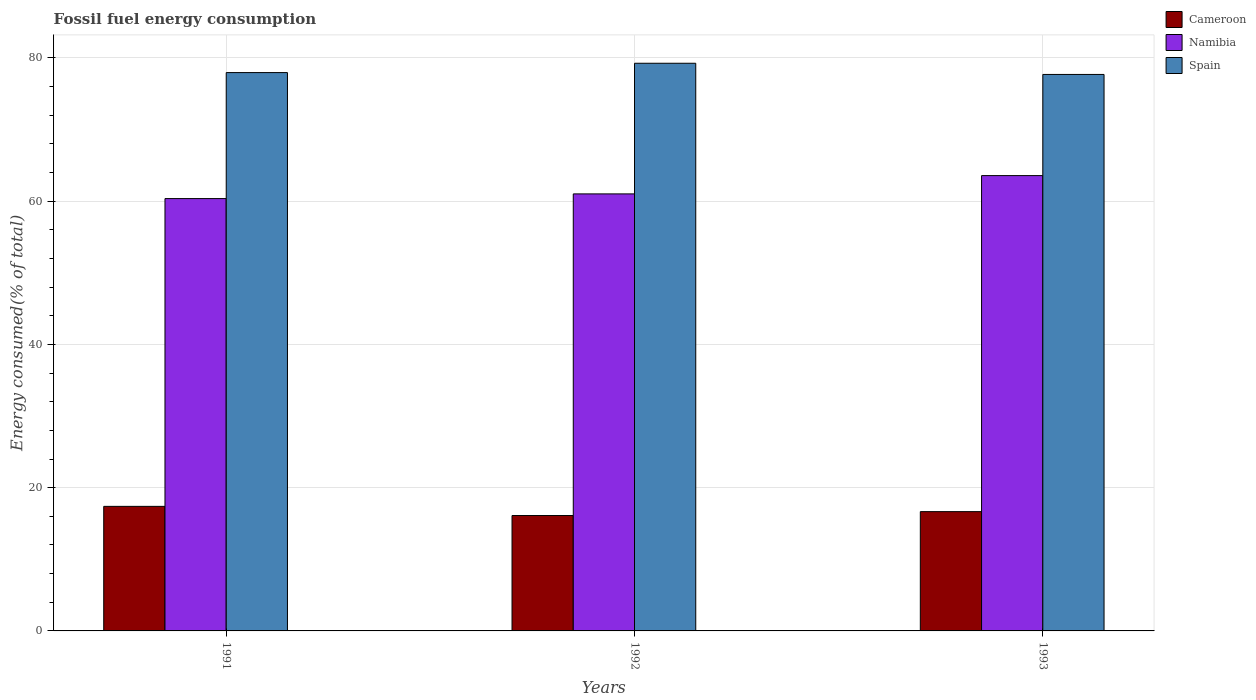How many different coloured bars are there?
Your answer should be very brief. 3. Are the number of bars per tick equal to the number of legend labels?
Offer a very short reply. Yes. Are the number of bars on each tick of the X-axis equal?
Give a very brief answer. Yes. How many bars are there on the 3rd tick from the right?
Keep it short and to the point. 3. In how many cases, is the number of bars for a given year not equal to the number of legend labels?
Your answer should be very brief. 0. What is the percentage of energy consumed in Cameroon in 1991?
Your answer should be very brief. 17.39. Across all years, what is the maximum percentage of energy consumed in Cameroon?
Your response must be concise. 17.39. Across all years, what is the minimum percentage of energy consumed in Cameroon?
Your answer should be very brief. 16.11. In which year was the percentage of energy consumed in Namibia minimum?
Keep it short and to the point. 1991. What is the total percentage of energy consumed in Spain in the graph?
Your answer should be compact. 234.9. What is the difference between the percentage of energy consumed in Namibia in 1991 and that in 1993?
Give a very brief answer. -3.21. What is the difference between the percentage of energy consumed in Cameroon in 1993 and the percentage of energy consumed in Spain in 1991?
Your answer should be very brief. -61.3. What is the average percentage of energy consumed in Spain per year?
Your answer should be very brief. 78.3. In the year 1992, what is the difference between the percentage of energy consumed in Namibia and percentage of energy consumed in Spain?
Your answer should be compact. -18.24. What is the ratio of the percentage of energy consumed in Cameroon in 1991 to that in 1992?
Make the answer very short. 1.08. Is the percentage of energy consumed in Namibia in 1991 less than that in 1993?
Your answer should be compact. Yes. What is the difference between the highest and the second highest percentage of energy consumed in Cameroon?
Your answer should be compact. 0.73. What is the difference between the highest and the lowest percentage of energy consumed in Spain?
Give a very brief answer. 1.56. Is the sum of the percentage of energy consumed in Cameroon in 1991 and 1992 greater than the maximum percentage of energy consumed in Namibia across all years?
Provide a short and direct response. No. What does the 3rd bar from the right in 1992 represents?
Provide a succinct answer. Cameroon. How many years are there in the graph?
Make the answer very short. 3. Are the values on the major ticks of Y-axis written in scientific E-notation?
Your answer should be very brief. No. How many legend labels are there?
Give a very brief answer. 3. What is the title of the graph?
Ensure brevity in your answer.  Fossil fuel energy consumption. Does "United States" appear as one of the legend labels in the graph?
Your answer should be compact. No. What is the label or title of the X-axis?
Give a very brief answer. Years. What is the label or title of the Y-axis?
Keep it short and to the point. Energy consumed(% of total). What is the Energy consumed(% of total) of Cameroon in 1991?
Your answer should be very brief. 17.39. What is the Energy consumed(% of total) in Namibia in 1991?
Give a very brief answer. 60.36. What is the Energy consumed(% of total) of Spain in 1991?
Ensure brevity in your answer.  77.95. What is the Energy consumed(% of total) in Cameroon in 1992?
Make the answer very short. 16.11. What is the Energy consumed(% of total) in Namibia in 1992?
Keep it short and to the point. 61.02. What is the Energy consumed(% of total) in Spain in 1992?
Keep it short and to the point. 79.25. What is the Energy consumed(% of total) in Cameroon in 1993?
Provide a short and direct response. 16.65. What is the Energy consumed(% of total) in Namibia in 1993?
Provide a succinct answer. 63.57. What is the Energy consumed(% of total) in Spain in 1993?
Your response must be concise. 77.69. Across all years, what is the maximum Energy consumed(% of total) in Cameroon?
Your response must be concise. 17.39. Across all years, what is the maximum Energy consumed(% of total) in Namibia?
Make the answer very short. 63.57. Across all years, what is the maximum Energy consumed(% of total) of Spain?
Your response must be concise. 79.25. Across all years, what is the minimum Energy consumed(% of total) of Cameroon?
Give a very brief answer. 16.11. Across all years, what is the minimum Energy consumed(% of total) in Namibia?
Provide a succinct answer. 60.36. Across all years, what is the minimum Energy consumed(% of total) of Spain?
Provide a short and direct response. 77.69. What is the total Energy consumed(% of total) in Cameroon in the graph?
Offer a terse response. 50.15. What is the total Energy consumed(% of total) of Namibia in the graph?
Your answer should be compact. 184.94. What is the total Energy consumed(% of total) in Spain in the graph?
Your answer should be compact. 234.9. What is the difference between the Energy consumed(% of total) in Cameroon in 1991 and that in 1992?
Ensure brevity in your answer.  1.28. What is the difference between the Energy consumed(% of total) of Namibia in 1991 and that in 1992?
Ensure brevity in your answer.  -0.66. What is the difference between the Energy consumed(% of total) of Spain in 1991 and that in 1992?
Keep it short and to the point. -1.3. What is the difference between the Energy consumed(% of total) in Cameroon in 1991 and that in 1993?
Provide a short and direct response. 0.73. What is the difference between the Energy consumed(% of total) in Namibia in 1991 and that in 1993?
Make the answer very short. -3.21. What is the difference between the Energy consumed(% of total) in Spain in 1991 and that in 1993?
Give a very brief answer. 0.26. What is the difference between the Energy consumed(% of total) in Cameroon in 1992 and that in 1993?
Your answer should be compact. -0.54. What is the difference between the Energy consumed(% of total) of Namibia in 1992 and that in 1993?
Keep it short and to the point. -2.55. What is the difference between the Energy consumed(% of total) of Spain in 1992 and that in 1993?
Offer a very short reply. 1.56. What is the difference between the Energy consumed(% of total) in Cameroon in 1991 and the Energy consumed(% of total) in Namibia in 1992?
Your response must be concise. -43.63. What is the difference between the Energy consumed(% of total) of Cameroon in 1991 and the Energy consumed(% of total) of Spain in 1992?
Your answer should be compact. -61.87. What is the difference between the Energy consumed(% of total) of Namibia in 1991 and the Energy consumed(% of total) of Spain in 1992?
Give a very brief answer. -18.89. What is the difference between the Energy consumed(% of total) of Cameroon in 1991 and the Energy consumed(% of total) of Namibia in 1993?
Give a very brief answer. -46.18. What is the difference between the Energy consumed(% of total) in Cameroon in 1991 and the Energy consumed(% of total) in Spain in 1993?
Your response must be concise. -60.3. What is the difference between the Energy consumed(% of total) in Namibia in 1991 and the Energy consumed(% of total) in Spain in 1993?
Your response must be concise. -17.33. What is the difference between the Energy consumed(% of total) of Cameroon in 1992 and the Energy consumed(% of total) of Namibia in 1993?
Your answer should be very brief. -47.46. What is the difference between the Energy consumed(% of total) of Cameroon in 1992 and the Energy consumed(% of total) of Spain in 1993?
Give a very brief answer. -61.58. What is the difference between the Energy consumed(% of total) of Namibia in 1992 and the Energy consumed(% of total) of Spain in 1993?
Keep it short and to the point. -16.68. What is the average Energy consumed(% of total) of Cameroon per year?
Your answer should be compact. 16.72. What is the average Energy consumed(% of total) of Namibia per year?
Make the answer very short. 61.65. What is the average Energy consumed(% of total) of Spain per year?
Provide a succinct answer. 78.3. In the year 1991, what is the difference between the Energy consumed(% of total) in Cameroon and Energy consumed(% of total) in Namibia?
Keep it short and to the point. -42.97. In the year 1991, what is the difference between the Energy consumed(% of total) in Cameroon and Energy consumed(% of total) in Spain?
Provide a succinct answer. -60.56. In the year 1991, what is the difference between the Energy consumed(% of total) of Namibia and Energy consumed(% of total) of Spain?
Give a very brief answer. -17.59. In the year 1992, what is the difference between the Energy consumed(% of total) in Cameroon and Energy consumed(% of total) in Namibia?
Offer a terse response. -44.91. In the year 1992, what is the difference between the Energy consumed(% of total) of Cameroon and Energy consumed(% of total) of Spain?
Keep it short and to the point. -63.14. In the year 1992, what is the difference between the Energy consumed(% of total) in Namibia and Energy consumed(% of total) in Spain?
Your response must be concise. -18.24. In the year 1993, what is the difference between the Energy consumed(% of total) in Cameroon and Energy consumed(% of total) in Namibia?
Your answer should be compact. -46.92. In the year 1993, what is the difference between the Energy consumed(% of total) of Cameroon and Energy consumed(% of total) of Spain?
Your answer should be compact. -61.04. In the year 1993, what is the difference between the Energy consumed(% of total) in Namibia and Energy consumed(% of total) in Spain?
Your answer should be compact. -14.12. What is the ratio of the Energy consumed(% of total) in Cameroon in 1991 to that in 1992?
Keep it short and to the point. 1.08. What is the ratio of the Energy consumed(% of total) of Spain in 1991 to that in 1992?
Your response must be concise. 0.98. What is the ratio of the Energy consumed(% of total) of Cameroon in 1991 to that in 1993?
Offer a very short reply. 1.04. What is the ratio of the Energy consumed(% of total) in Namibia in 1991 to that in 1993?
Provide a succinct answer. 0.95. What is the ratio of the Energy consumed(% of total) in Spain in 1991 to that in 1993?
Make the answer very short. 1. What is the ratio of the Energy consumed(% of total) of Cameroon in 1992 to that in 1993?
Your answer should be very brief. 0.97. What is the ratio of the Energy consumed(% of total) of Namibia in 1992 to that in 1993?
Provide a succinct answer. 0.96. What is the ratio of the Energy consumed(% of total) in Spain in 1992 to that in 1993?
Give a very brief answer. 1.02. What is the difference between the highest and the second highest Energy consumed(% of total) of Cameroon?
Offer a very short reply. 0.73. What is the difference between the highest and the second highest Energy consumed(% of total) of Namibia?
Your answer should be very brief. 2.55. What is the difference between the highest and the second highest Energy consumed(% of total) in Spain?
Provide a short and direct response. 1.3. What is the difference between the highest and the lowest Energy consumed(% of total) in Cameroon?
Provide a short and direct response. 1.28. What is the difference between the highest and the lowest Energy consumed(% of total) in Namibia?
Make the answer very short. 3.21. What is the difference between the highest and the lowest Energy consumed(% of total) of Spain?
Make the answer very short. 1.56. 